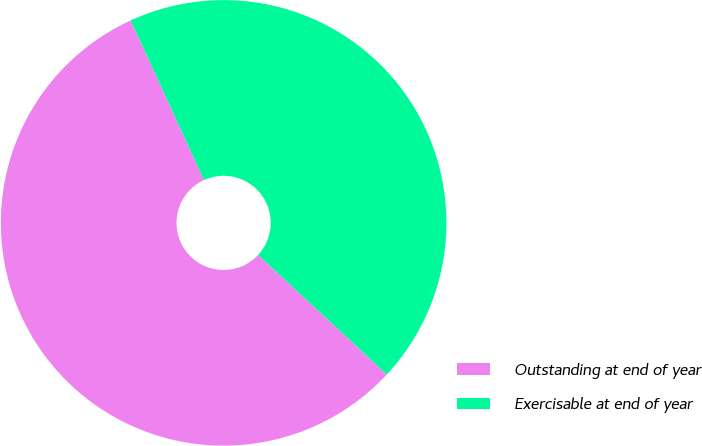<chart> <loc_0><loc_0><loc_500><loc_500><pie_chart><fcel>Outstanding at end of year<fcel>Exercisable at end of year<nl><fcel>56.23%<fcel>43.77%<nl></chart> 